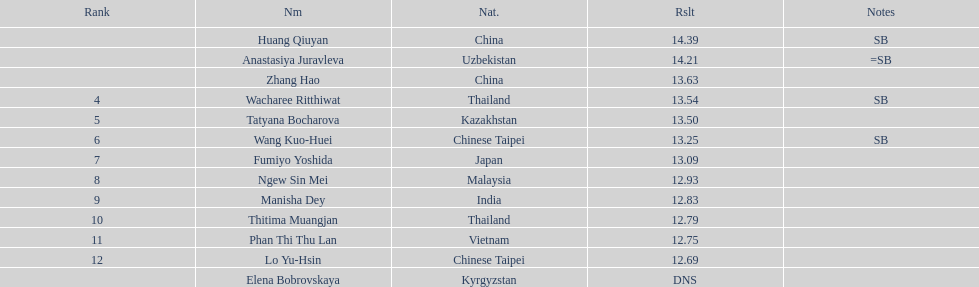What is the number of different nationalities represented by the top 5 athletes? 4. 